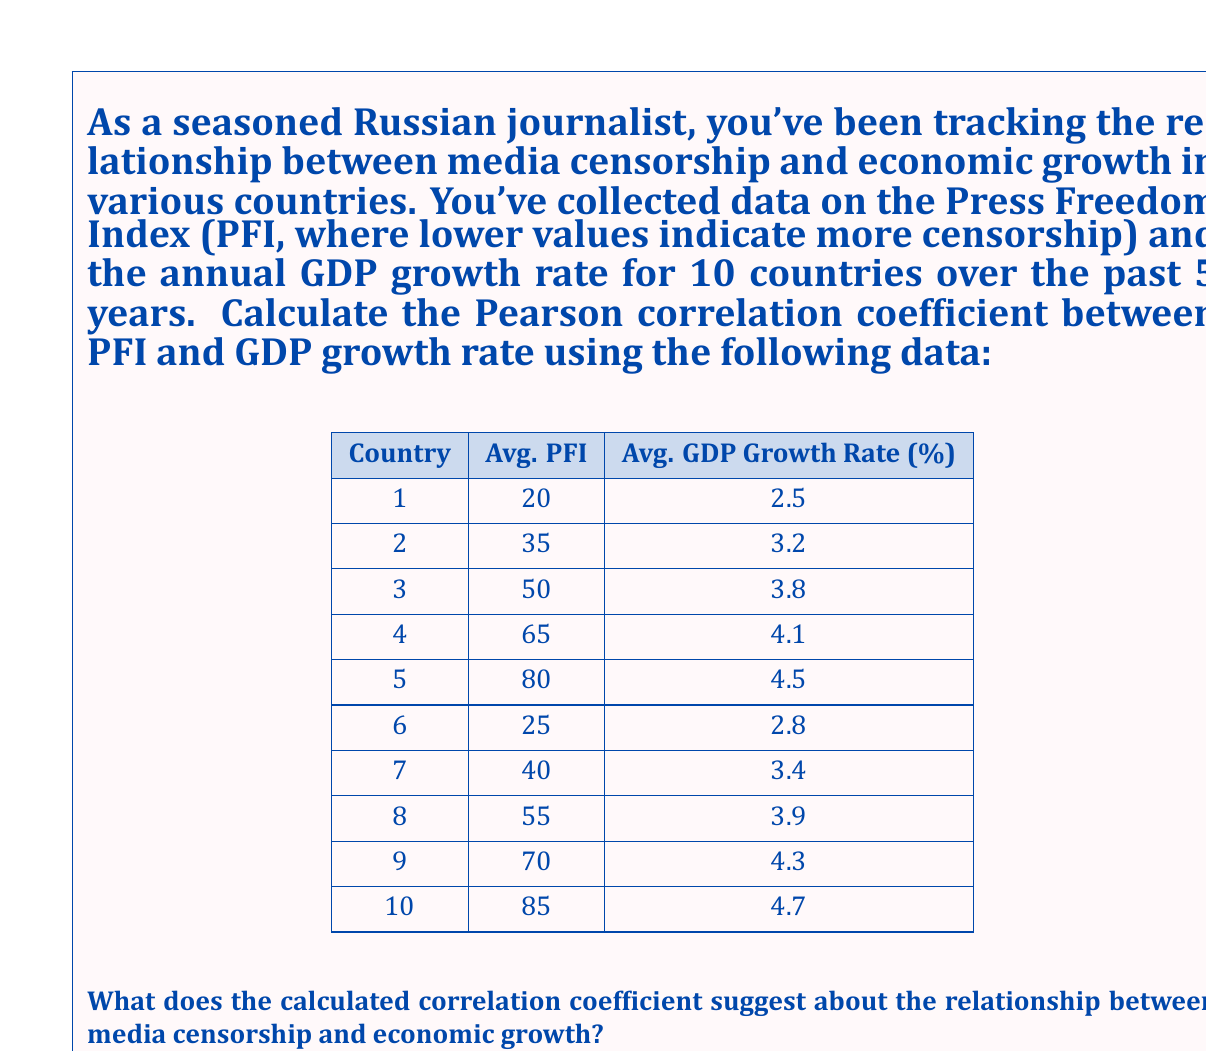Show me your answer to this math problem. To calculate the Pearson correlation coefficient (r) between the Press Freedom Index (PFI) and GDP growth rate, we'll use the formula:

$$ r = \frac{\sum_{i=1}^{n} (x_i - \bar{x})(y_i - \bar{y})}{\sqrt{\sum_{i=1}^{n} (x_i - \bar{x})^2 \sum_{i=1}^{n} (y_i - \bar{y})^2}} $$

Where:
$x_i$ = PFI values
$y_i$ = GDP growth rate values
$\bar{x}$ = mean of PFI values
$\bar{y}$ = mean of GDP growth rate values
$n$ = number of data points (10 in this case)

Step 1: Calculate means
$\bar{x} = \frac{20 + 35 + 50 + 65 + 80 + 25 + 40 + 55 + 70 + 85}{10} = 52.5$
$\bar{y} = \frac{2.5 + 3.2 + 3.8 + 4.1 + 4.5 + 2.8 + 3.4 + 3.9 + 4.3 + 4.7}{10} = 3.72$

Step 2: Calculate $(x_i - \bar{x})$, $(y_i - \bar{y})$, $(x_i - \bar{x})^2$, $(y_i - \bar{y})^2$, and $(x_i - \bar{x})(y_i - \bar{y})$ for each data point.

Step 3: Sum up the calculated values:
$\sum (x_i - \bar{x})(y_i - \bar{y}) = 665.75$
$\sum (x_i - \bar{x})^2 = 11312.5$
$\sum (y_i - \bar{y})^2 = 4.246$

Step 4: Apply the formula:

$$ r = \frac{665.75}{\sqrt{11312.5 \times 4.246}} = \frac{665.75}{218.97} = 0.9742 $$

The correlation coefficient is approximately 0.9742.

This strong positive correlation suggests that as the Press Freedom Index increases (indicating less censorship), there is a tendency for the GDP growth rate to increase as well. In the context of media censorship and economic indicators, this implies that countries with less media censorship (higher PFI) tend to have higher economic growth rates.

As a seasoned Russian journalist, this finding underscores the importance of press freedom not only for the integrity of journalism but also for potential economic benefits. It supports the notion that a free press might contribute to a more robust economic environment, possibly through increased transparency, better-informed decision-making, and improved accountability.
Answer: The Pearson correlation coefficient between the Press Freedom Index and GDP growth rate is approximately 0.9742, indicating a strong positive correlation. This suggests that countries with higher press freedom (less censorship) tend to have higher GDP growth rates. 